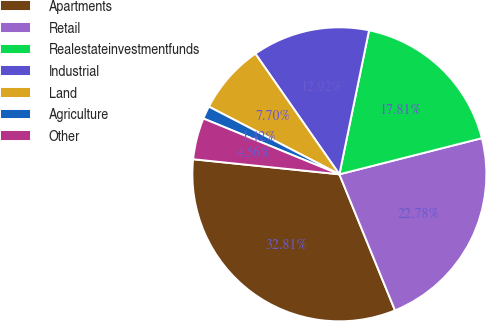Convert chart to OTSL. <chart><loc_0><loc_0><loc_500><loc_500><pie_chart><fcel>Apartments<fcel>Retail<fcel>Realestateinvestmentfunds<fcel>Industrial<fcel>Land<fcel>Agriculture<fcel>Other<nl><fcel>32.81%<fcel>22.78%<fcel>17.81%<fcel>12.92%<fcel>7.7%<fcel>1.42%<fcel>4.56%<nl></chart> 